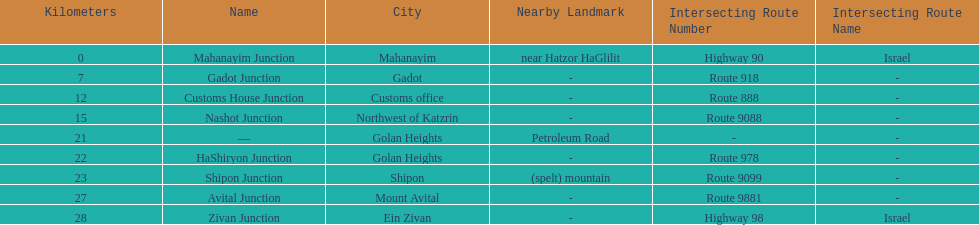What is the last junction on highway 91? Zivan Junction. 